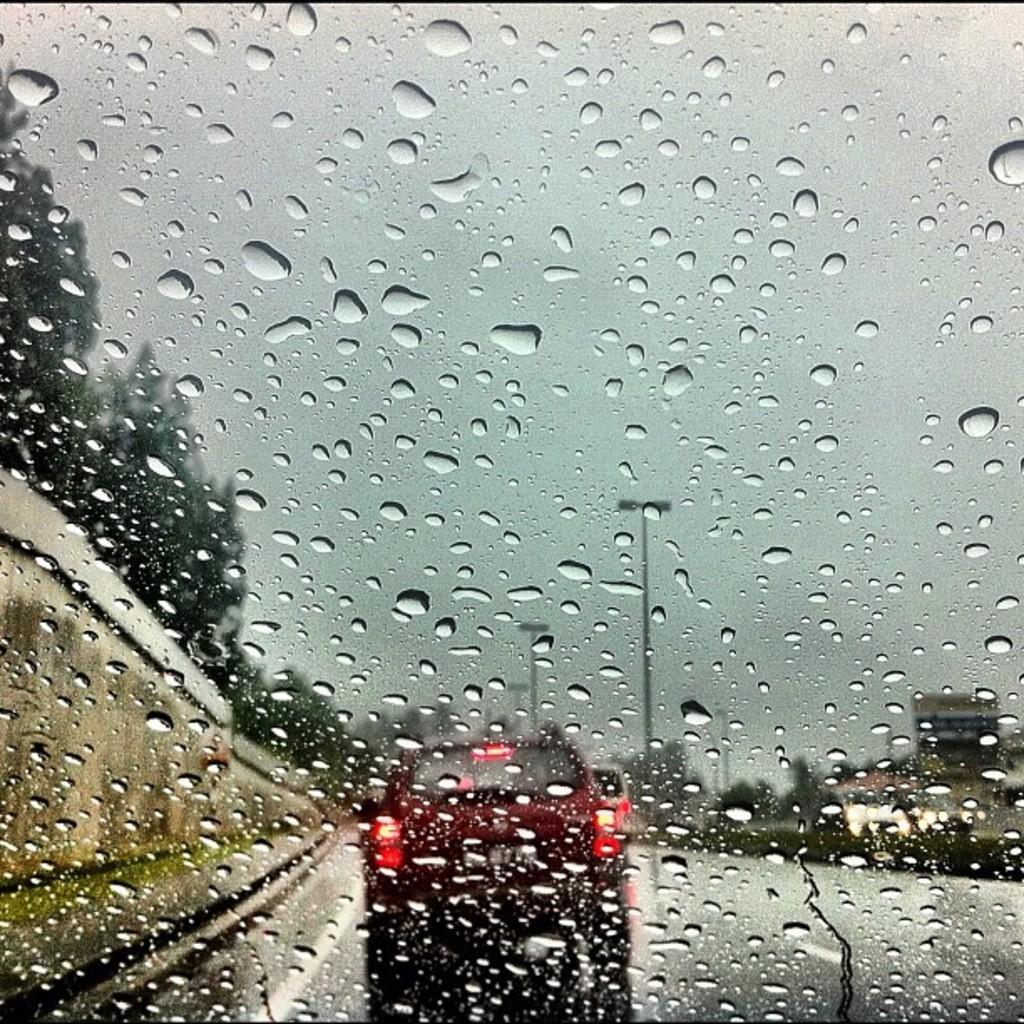Describe this image in one or two sentences. In this image we can see water droplets on the glass, in front of it there is a re color car on the road, and there are some street lights, and we can see some trees at left side of the image. 